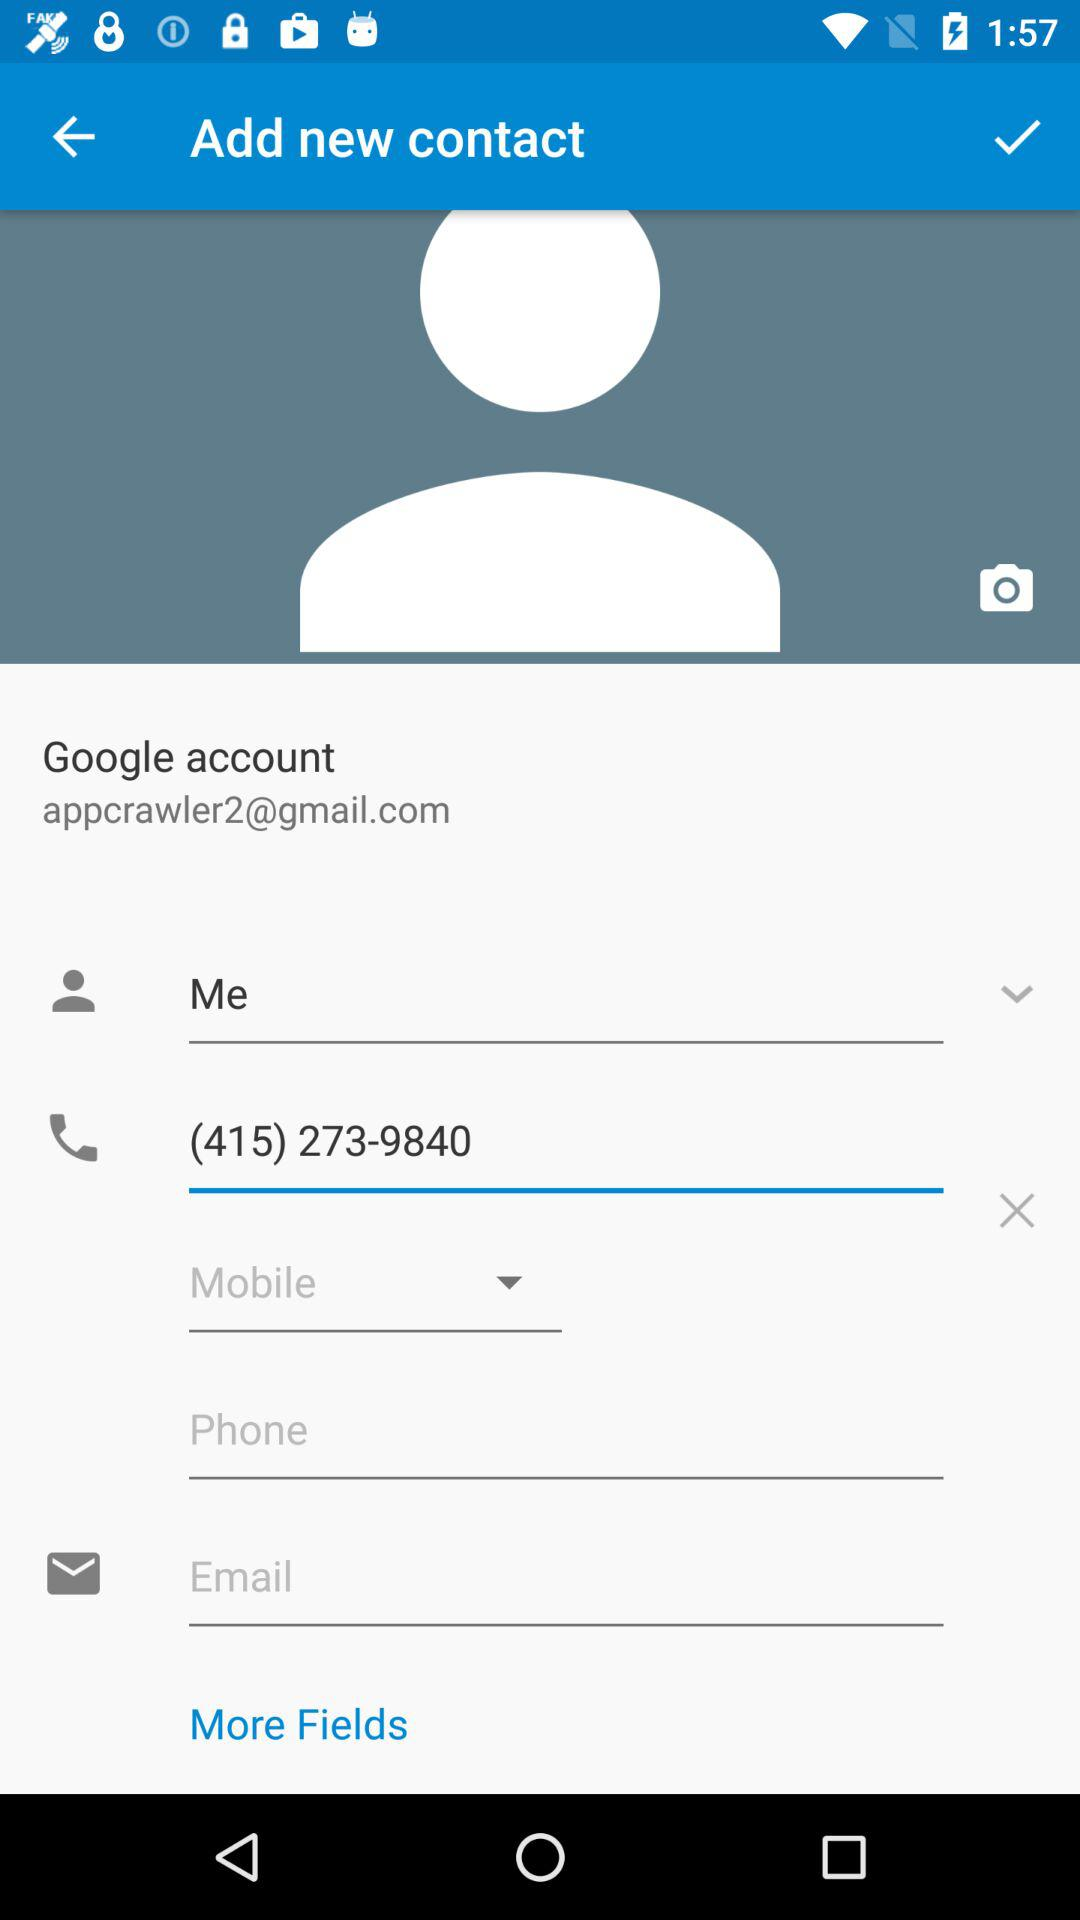What is the given phone number? The given phone number is (415) 273-9840. 